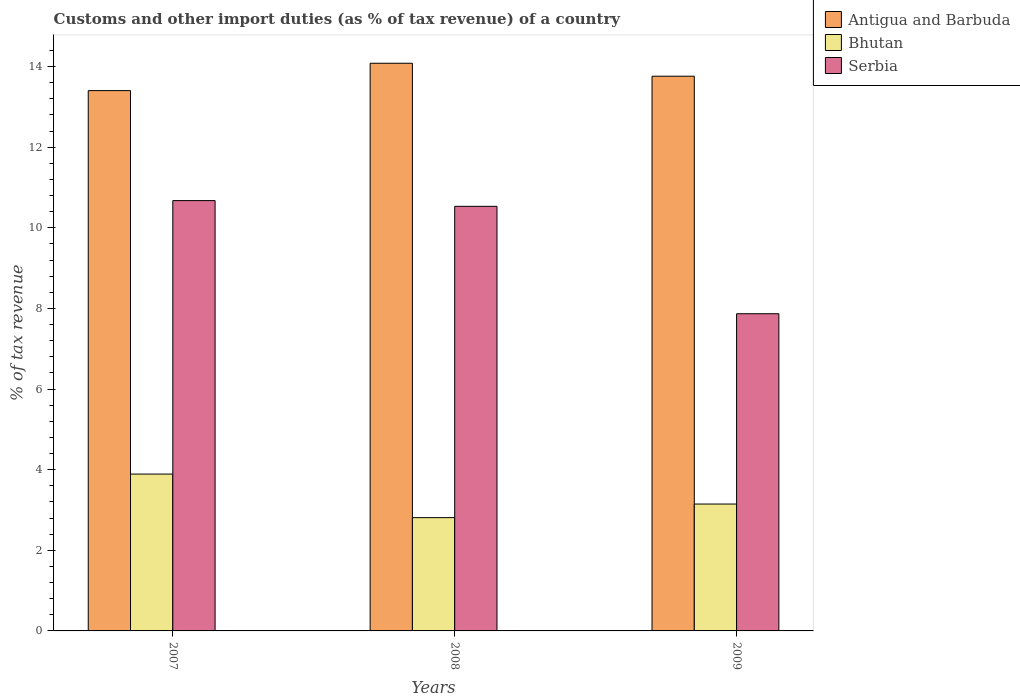How many different coloured bars are there?
Your answer should be compact. 3. How many groups of bars are there?
Ensure brevity in your answer.  3. Are the number of bars per tick equal to the number of legend labels?
Provide a succinct answer. Yes. How many bars are there on the 1st tick from the left?
Provide a succinct answer. 3. How many bars are there on the 1st tick from the right?
Your response must be concise. 3. In how many cases, is the number of bars for a given year not equal to the number of legend labels?
Your answer should be compact. 0. What is the percentage of tax revenue from customs in Serbia in 2009?
Offer a terse response. 7.87. Across all years, what is the maximum percentage of tax revenue from customs in Antigua and Barbuda?
Ensure brevity in your answer.  14.08. Across all years, what is the minimum percentage of tax revenue from customs in Bhutan?
Your answer should be compact. 2.81. What is the total percentage of tax revenue from customs in Antigua and Barbuda in the graph?
Keep it short and to the point. 41.24. What is the difference between the percentage of tax revenue from customs in Serbia in 2007 and that in 2009?
Ensure brevity in your answer.  2.81. What is the difference between the percentage of tax revenue from customs in Serbia in 2008 and the percentage of tax revenue from customs in Antigua and Barbuda in 2007?
Your answer should be compact. -2.87. What is the average percentage of tax revenue from customs in Bhutan per year?
Offer a terse response. 3.28. In the year 2007, what is the difference between the percentage of tax revenue from customs in Antigua and Barbuda and percentage of tax revenue from customs in Bhutan?
Make the answer very short. 9.51. What is the ratio of the percentage of tax revenue from customs in Antigua and Barbuda in 2008 to that in 2009?
Your response must be concise. 1.02. Is the difference between the percentage of tax revenue from customs in Antigua and Barbuda in 2008 and 2009 greater than the difference between the percentage of tax revenue from customs in Bhutan in 2008 and 2009?
Make the answer very short. Yes. What is the difference between the highest and the second highest percentage of tax revenue from customs in Serbia?
Keep it short and to the point. 0.14. What is the difference between the highest and the lowest percentage of tax revenue from customs in Antigua and Barbuda?
Make the answer very short. 0.68. In how many years, is the percentage of tax revenue from customs in Antigua and Barbuda greater than the average percentage of tax revenue from customs in Antigua and Barbuda taken over all years?
Ensure brevity in your answer.  2. What does the 3rd bar from the left in 2007 represents?
Ensure brevity in your answer.  Serbia. What does the 3rd bar from the right in 2008 represents?
Give a very brief answer. Antigua and Barbuda. How many bars are there?
Ensure brevity in your answer.  9. How many years are there in the graph?
Your answer should be compact. 3. What is the difference between two consecutive major ticks on the Y-axis?
Keep it short and to the point. 2. How many legend labels are there?
Ensure brevity in your answer.  3. How are the legend labels stacked?
Provide a succinct answer. Vertical. What is the title of the graph?
Give a very brief answer. Customs and other import duties (as % of tax revenue) of a country. Does "Djibouti" appear as one of the legend labels in the graph?
Give a very brief answer. No. What is the label or title of the Y-axis?
Give a very brief answer. % of tax revenue. What is the % of tax revenue in Antigua and Barbuda in 2007?
Keep it short and to the point. 13.4. What is the % of tax revenue in Bhutan in 2007?
Your answer should be compact. 3.89. What is the % of tax revenue of Serbia in 2007?
Give a very brief answer. 10.67. What is the % of tax revenue of Antigua and Barbuda in 2008?
Offer a very short reply. 14.08. What is the % of tax revenue in Bhutan in 2008?
Offer a very short reply. 2.81. What is the % of tax revenue of Serbia in 2008?
Ensure brevity in your answer.  10.53. What is the % of tax revenue of Antigua and Barbuda in 2009?
Provide a succinct answer. 13.76. What is the % of tax revenue of Bhutan in 2009?
Your answer should be very brief. 3.15. What is the % of tax revenue of Serbia in 2009?
Make the answer very short. 7.87. Across all years, what is the maximum % of tax revenue in Antigua and Barbuda?
Provide a short and direct response. 14.08. Across all years, what is the maximum % of tax revenue of Bhutan?
Your answer should be very brief. 3.89. Across all years, what is the maximum % of tax revenue in Serbia?
Offer a terse response. 10.67. Across all years, what is the minimum % of tax revenue of Antigua and Barbuda?
Ensure brevity in your answer.  13.4. Across all years, what is the minimum % of tax revenue of Bhutan?
Give a very brief answer. 2.81. Across all years, what is the minimum % of tax revenue of Serbia?
Give a very brief answer. 7.87. What is the total % of tax revenue of Antigua and Barbuda in the graph?
Provide a short and direct response. 41.24. What is the total % of tax revenue in Bhutan in the graph?
Make the answer very short. 9.85. What is the total % of tax revenue of Serbia in the graph?
Provide a short and direct response. 29.08. What is the difference between the % of tax revenue of Antigua and Barbuda in 2007 and that in 2008?
Provide a succinct answer. -0.68. What is the difference between the % of tax revenue of Bhutan in 2007 and that in 2008?
Your answer should be compact. 1.08. What is the difference between the % of tax revenue in Serbia in 2007 and that in 2008?
Offer a terse response. 0.14. What is the difference between the % of tax revenue in Antigua and Barbuda in 2007 and that in 2009?
Keep it short and to the point. -0.36. What is the difference between the % of tax revenue of Bhutan in 2007 and that in 2009?
Ensure brevity in your answer.  0.74. What is the difference between the % of tax revenue in Serbia in 2007 and that in 2009?
Provide a succinct answer. 2.81. What is the difference between the % of tax revenue in Antigua and Barbuda in 2008 and that in 2009?
Ensure brevity in your answer.  0.32. What is the difference between the % of tax revenue in Bhutan in 2008 and that in 2009?
Offer a terse response. -0.34. What is the difference between the % of tax revenue in Serbia in 2008 and that in 2009?
Offer a terse response. 2.66. What is the difference between the % of tax revenue of Antigua and Barbuda in 2007 and the % of tax revenue of Bhutan in 2008?
Ensure brevity in your answer.  10.59. What is the difference between the % of tax revenue of Antigua and Barbuda in 2007 and the % of tax revenue of Serbia in 2008?
Offer a very short reply. 2.87. What is the difference between the % of tax revenue in Bhutan in 2007 and the % of tax revenue in Serbia in 2008?
Offer a very short reply. -6.64. What is the difference between the % of tax revenue of Antigua and Barbuda in 2007 and the % of tax revenue of Bhutan in 2009?
Keep it short and to the point. 10.26. What is the difference between the % of tax revenue of Antigua and Barbuda in 2007 and the % of tax revenue of Serbia in 2009?
Provide a succinct answer. 5.53. What is the difference between the % of tax revenue in Bhutan in 2007 and the % of tax revenue in Serbia in 2009?
Ensure brevity in your answer.  -3.98. What is the difference between the % of tax revenue of Antigua and Barbuda in 2008 and the % of tax revenue of Bhutan in 2009?
Keep it short and to the point. 10.93. What is the difference between the % of tax revenue in Antigua and Barbuda in 2008 and the % of tax revenue in Serbia in 2009?
Your answer should be compact. 6.21. What is the difference between the % of tax revenue of Bhutan in 2008 and the % of tax revenue of Serbia in 2009?
Your answer should be compact. -5.06. What is the average % of tax revenue in Antigua and Barbuda per year?
Your answer should be very brief. 13.75. What is the average % of tax revenue in Bhutan per year?
Keep it short and to the point. 3.28. What is the average % of tax revenue of Serbia per year?
Ensure brevity in your answer.  9.69. In the year 2007, what is the difference between the % of tax revenue in Antigua and Barbuda and % of tax revenue in Bhutan?
Your answer should be very brief. 9.51. In the year 2007, what is the difference between the % of tax revenue in Antigua and Barbuda and % of tax revenue in Serbia?
Your answer should be very brief. 2.73. In the year 2007, what is the difference between the % of tax revenue in Bhutan and % of tax revenue in Serbia?
Your answer should be very brief. -6.78. In the year 2008, what is the difference between the % of tax revenue of Antigua and Barbuda and % of tax revenue of Bhutan?
Offer a terse response. 11.27. In the year 2008, what is the difference between the % of tax revenue of Antigua and Barbuda and % of tax revenue of Serbia?
Your answer should be compact. 3.55. In the year 2008, what is the difference between the % of tax revenue in Bhutan and % of tax revenue in Serbia?
Provide a short and direct response. -7.72. In the year 2009, what is the difference between the % of tax revenue of Antigua and Barbuda and % of tax revenue of Bhutan?
Provide a short and direct response. 10.61. In the year 2009, what is the difference between the % of tax revenue in Antigua and Barbuda and % of tax revenue in Serbia?
Offer a very short reply. 5.89. In the year 2009, what is the difference between the % of tax revenue of Bhutan and % of tax revenue of Serbia?
Give a very brief answer. -4.72. What is the ratio of the % of tax revenue in Antigua and Barbuda in 2007 to that in 2008?
Your response must be concise. 0.95. What is the ratio of the % of tax revenue of Bhutan in 2007 to that in 2008?
Keep it short and to the point. 1.38. What is the ratio of the % of tax revenue of Serbia in 2007 to that in 2008?
Offer a terse response. 1.01. What is the ratio of the % of tax revenue of Bhutan in 2007 to that in 2009?
Offer a very short reply. 1.24. What is the ratio of the % of tax revenue of Serbia in 2007 to that in 2009?
Make the answer very short. 1.36. What is the ratio of the % of tax revenue in Antigua and Barbuda in 2008 to that in 2009?
Offer a very short reply. 1.02. What is the ratio of the % of tax revenue in Bhutan in 2008 to that in 2009?
Ensure brevity in your answer.  0.89. What is the ratio of the % of tax revenue in Serbia in 2008 to that in 2009?
Ensure brevity in your answer.  1.34. What is the difference between the highest and the second highest % of tax revenue of Antigua and Barbuda?
Ensure brevity in your answer.  0.32. What is the difference between the highest and the second highest % of tax revenue in Bhutan?
Offer a terse response. 0.74. What is the difference between the highest and the second highest % of tax revenue of Serbia?
Give a very brief answer. 0.14. What is the difference between the highest and the lowest % of tax revenue of Antigua and Barbuda?
Make the answer very short. 0.68. What is the difference between the highest and the lowest % of tax revenue in Bhutan?
Ensure brevity in your answer.  1.08. What is the difference between the highest and the lowest % of tax revenue in Serbia?
Make the answer very short. 2.81. 